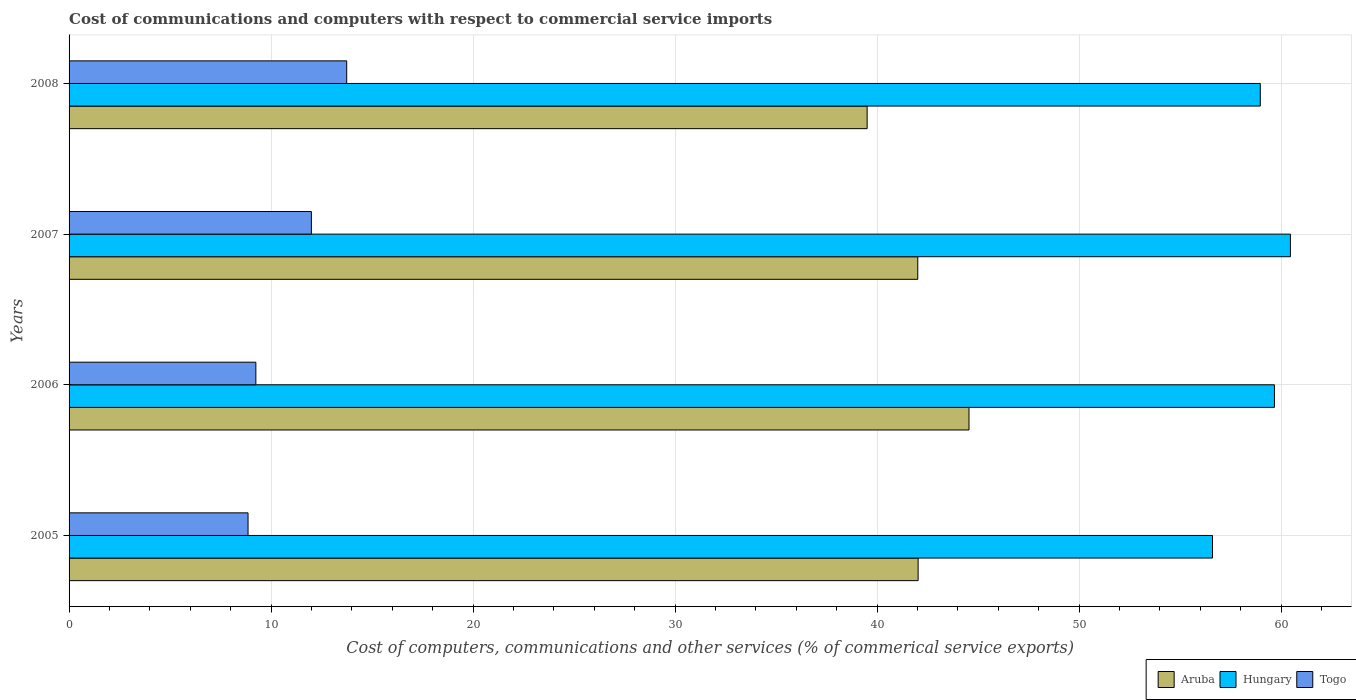Are the number of bars per tick equal to the number of legend labels?
Your response must be concise. Yes. How many bars are there on the 3rd tick from the top?
Your answer should be compact. 3. What is the label of the 3rd group of bars from the top?
Make the answer very short. 2006. In how many cases, is the number of bars for a given year not equal to the number of legend labels?
Ensure brevity in your answer.  0. What is the cost of communications and computers in Aruba in 2005?
Offer a terse response. 42.03. Across all years, what is the maximum cost of communications and computers in Hungary?
Provide a short and direct response. 60.46. Across all years, what is the minimum cost of communications and computers in Hungary?
Your answer should be compact. 56.61. What is the total cost of communications and computers in Togo in the graph?
Your response must be concise. 43.85. What is the difference between the cost of communications and computers in Aruba in 2007 and that in 2008?
Provide a succinct answer. 2.51. What is the difference between the cost of communications and computers in Togo in 2008 and the cost of communications and computers in Aruba in 2007?
Your answer should be compact. -28.27. What is the average cost of communications and computers in Hungary per year?
Offer a very short reply. 58.93. In the year 2005, what is the difference between the cost of communications and computers in Togo and cost of communications and computers in Hungary?
Give a very brief answer. -47.75. What is the ratio of the cost of communications and computers in Togo in 2007 to that in 2008?
Ensure brevity in your answer.  0.87. Is the difference between the cost of communications and computers in Togo in 2006 and 2007 greater than the difference between the cost of communications and computers in Hungary in 2006 and 2007?
Provide a short and direct response. No. What is the difference between the highest and the second highest cost of communications and computers in Togo?
Ensure brevity in your answer.  1.75. What is the difference between the highest and the lowest cost of communications and computers in Hungary?
Ensure brevity in your answer.  3.86. In how many years, is the cost of communications and computers in Aruba greater than the average cost of communications and computers in Aruba taken over all years?
Offer a very short reply. 2. Is the sum of the cost of communications and computers in Togo in 2005 and 2008 greater than the maximum cost of communications and computers in Aruba across all years?
Ensure brevity in your answer.  No. What does the 2nd bar from the top in 2008 represents?
Make the answer very short. Hungary. What does the 1st bar from the bottom in 2006 represents?
Offer a very short reply. Aruba. Are all the bars in the graph horizontal?
Offer a terse response. Yes. What is the difference between two consecutive major ticks on the X-axis?
Offer a very short reply. 10. Are the values on the major ticks of X-axis written in scientific E-notation?
Provide a short and direct response. No. How are the legend labels stacked?
Ensure brevity in your answer.  Horizontal. What is the title of the graph?
Keep it short and to the point. Cost of communications and computers with respect to commercial service imports. Does "Azerbaijan" appear as one of the legend labels in the graph?
Offer a terse response. No. What is the label or title of the X-axis?
Your answer should be compact. Cost of computers, communications and other services (% of commerical service exports). What is the Cost of computers, communications and other services (% of commerical service exports) in Aruba in 2005?
Your response must be concise. 42.03. What is the Cost of computers, communications and other services (% of commerical service exports) of Hungary in 2005?
Ensure brevity in your answer.  56.61. What is the Cost of computers, communications and other services (% of commerical service exports) of Togo in 2005?
Your response must be concise. 8.86. What is the Cost of computers, communications and other services (% of commerical service exports) of Aruba in 2006?
Offer a very short reply. 44.55. What is the Cost of computers, communications and other services (% of commerical service exports) in Hungary in 2006?
Make the answer very short. 59.67. What is the Cost of computers, communications and other services (% of commerical service exports) in Togo in 2006?
Your answer should be very brief. 9.25. What is the Cost of computers, communications and other services (% of commerical service exports) in Aruba in 2007?
Offer a very short reply. 42.01. What is the Cost of computers, communications and other services (% of commerical service exports) in Hungary in 2007?
Keep it short and to the point. 60.46. What is the Cost of computers, communications and other services (% of commerical service exports) in Togo in 2007?
Provide a short and direct response. 11.99. What is the Cost of computers, communications and other services (% of commerical service exports) in Aruba in 2008?
Your answer should be very brief. 39.51. What is the Cost of computers, communications and other services (% of commerical service exports) of Hungary in 2008?
Provide a succinct answer. 58.97. What is the Cost of computers, communications and other services (% of commerical service exports) of Togo in 2008?
Provide a short and direct response. 13.74. Across all years, what is the maximum Cost of computers, communications and other services (% of commerical service exports) of Aruba?
Make the answer very short. 44.55. Across all years, what is the maximum Cost of computers, communications and other services (% of commerical service exports) of Hungary?
Keep it short and to the point. 60.46. Across all years, what is the maximum Cost of computers, communications and other services (% of commerical service exports) of Togo?
Make the answer very short. 13.74. Across all years, what is the minimum Cost of computers, communications and other services (% of commerical service exports) of Aruba?
Offer a terse response. 39.51. Across all years, what is the minimum Cost of computers, communications and other services (% of commerical service exports) of Hungary?
Keep it short and to the point. 56.61. Across all years, what is the minimum Cost of computers, communications and other services (% of commerical service exports) of Togo?
Your response must be concise. 8.86. What is the total Cost of computers, communications and other services (% of commerical service exports) in Aruba in the graph?
Offer a terse response. 168.11. What is the total Cost of computers, communications and other services (% of commerical service exports) in Hungary in the graph?
Ensure brevity in your answer.  235.71. What is the total Cost of computers, communications and other services (% of commerical service exports) of Togo in the graph?
Make the answer very short. 43.85. What is the difference between the Cost of computers, communications and other services (% of commerical service exports) of Aruba in 2005 and that in 2006?
Offer a very short reply. -2.52. What is the difference between the Cost of computers, communications and other services (% of commerical service exports) of Hungary in 2005 and that in 2006?
Make the answer very short. -3.06. What is the difference between the Cost of computers, communications and other services (% of commerical service exports) in Togo in 2005 and that in 2006?
Offer a very short reply. -0.39. What is the difference between the Cost of computers, communications and other services (% of commerical service exports) of Aruba in 2005 and that in 2007?
Offer a terse response. 0.02. What is the difference between the Cost of computers, communications and other services (% of commerical service exports) of Hungary in 2005 and that in 2007?
Ensure brevity in your answer.  -3.86. What is the difference between the Cost of computers, communications and other services (% of commerical service exports) in Togo in 2005 and that in 2007?
Keep it short and to the point. -3.14. What is the difference between the Cost of computers, communications and other services (% of commerical service exports) of Aruba in 2005 and that in 2008?
Keep it short and to the point. 2.52. What is the difference between the Cost of computers, communications and other services (% of commerical service exports) in Hungary in 2005 and that in 2008?
Provide a short and direct response. -2.36. What is the difference between the Cost of computers, communications and other services (% of commerical service exports) of Togo in 2005 and that in 2008?
Offer a very short reply. -4.88. What is the difference between the Cost of computers, communications and other services (% of commerical service exports) of Aruba in 2006 and that in 2007?
Your answer should be compact. 2.54. What is the difference between the Cost of computers, communications and other services (% of commerical service exports) of Hungary in 2006 and that in 2007?
Your response must be concise. -0.79. What is the difference between the Cost of computers, communications and other services (% of commerical service exports) of Togo in 2006 and that in 2007?
Ensure brevity in your answer.  -2.75. What is the difference between the Cost of computers, communications and other services (% of commerical service exports) of Aruba in 2006 and that in 2008?
Offer a terse response. 5.04. What is the difference between the Cost of computers, communications and other services (% of commerical service exports) of Hungary in 2006 and that in 2008?
Make the answer very short. 0.7. What is the difference between the Cost of computers, communications and other services (% of commerical service exports) in Togo in 2006 and that in 2008?
Ensure brevity in your answer.  -4.5. What is the difference between the Cost of computers, communications and other services (% of commerical service exports) of Aruba in 2007 and that in 2008?
Offer a very short reply. 2.51. What is the difference between the Cost of computers, communications and other services (% of commerical service exports) in Hungary in 2007 and that in 2008?
Make the answer very short. 1.49. What is the difference between the Cost of computers, communications and other services (% of commerical service exports) of Togo in 2007 and that in 2008?
Your answer should be very brief. -1.75. What is the difference between the Cost of computers, communications and other services (% of commerical service exports) in Aruba in 2005 and the Cost of computers, communications and other services (% of commerical service exports) in Hungary in 2006?
Keep it short and to the point. -17.64. What is the difference between the Cost of computers, communications and other services (% of commerical service exports) of Aruba in 2005 and the Cost of computers, communications and other services (% of commerical service exports) of Togo in 2006?
Offer a terse response. 32.78. What is the difference between the Cost of computers, communications and other services (% of commerical service exports) in Hungary in 2005 and the Cost of computers, communications and other services (% of commerical service exports) in Togo in 2006?
Offer a terse response. 47.36. What is the difference between the Cost of computers, communications and other services (% of commerical service exports) of Aruba in 2005 and the Cost of computers, communications and other services (% of commerical service exports) of Hungary in 2007?
Keep it short and to the point. -18.43. What is the difference between the Cost of computers, communications and other services (% of commerical service exports) of Aruba in 2005 and the Cost of computers, communications and other services (% of commerical service exports) of Togo in 2007?
Your answer should be very brief. 30.04. What is the difference between the Cost of computers, communications and other services (% of commerical service exports) in Hungary in 2005 and the Cost of computers, communications and other services (% of commerical service exports) in Togo in 2007?
Your answer should be very brief. 44.61. What is the difference between the Cost of computers, communications and other services (% of commerical service exports) of Aruba in 2005 and the Cost of computers, communications and other services (% of commerical service exports) of Hungary in 2008?
Keep it short and to the point. -16.94. What is the difference between the Cost of computers, communications and other services (% of commerical service exports) of Aruba in 2005 and the Cost of computers, communications and other services (% of commerical service exports) of Togo in 2008?
Offer a very short reply. 28.29. What is the difference between the Cost of computers, communications and other services (% of commerical service exports) in Hungary in 2005 and the Cost of computers, communications and other services (% of commerical service exports) in Togo in 2008?
Provide a short and direct response. 42.86. What is the difference between the Cost of computers, communications and other services (% of commerical service exports) in Aruba in 2006 and the Cost of computers, communications and other services (% of commerical service exports) in Hungary in 2007?
Make the answer very short. -15.91. What is the difference between the Cost of computers, communications and other services (% of commerical service exports) in Aruba in 2006 and the Cost of computers, communications and other services (% of commerical service exports) in Togo in 2007?
Offer a very short reply. 32.56. What is the difference between the Cost of computers, communications and other services (% of commerical service exports) of Hungary in 2006 and the Cost of computers, communications and other services (% of commerical service exports) of Togo in 2007?
Make the answer very short. 47.68. What is the difference between the Cost of computers, communications and other services (% of commerical service exports) of Aruba in 2006 and the Cost of computers, communications and other services (% of commerical service exports) of Hungary in 2008?
Make the answer very short. -14.42. What is the difference between the Cost of computers, communications and other services (% of commerical service exports) of Aruba in 2006 and the Cost of computers, communications and other services (% of commerical service exports) of Togo in 2008?
Give a very brief answer. 30.81. What is the difference between the Cost of computers, communications and other services (% of commerical service exports) of Hungary in 2006 and the Cost of computers, communications and other services (% of commerical service exports) of Togo in 2008?
Offer a very short reply. 45.93. What is the difference between the Cost of computers, communications and other services (% of commerical service exports) in Aruba in 2007 and the Cost of computers, communications and other services (% of commerical service exports) in Hungary in 2008?
Provide a succinct answer. -16.96. What is the difference between the Cost of computers, communications and other services (% of commerical service exports) of Aruba in 2007 and the Cost of computers, communications and other services (% of commerical service exports) of Togo in 2008?
Keep it short and to the point. 28.27. What is the difference between the Cost of computers, communications and other services (% of commerical service exports) of Hungary in 2007 and the Cost of computers, communications and other services (% of commerical service exports) of Togo in 2008?
Your answer should be compact. 46.72. What is the average Cost of computers, communications and other services (% of commerical service exports) of Aruba per year?
Your response must be concise. 42.03. What is the average Cost of computers, communications and other services (% of commerical service exports) in Hungary per year?
Offer a terse response. 58.93. What is the average Cost of computers, communications and other services (% of commerical service exports) in Togo per year?
Your answer should be very brief. 10.96. In the year 2005, what is the difference between the Cost of computers, communications and other services (% of commerical service exports) of Aruba and Cost of computers, communications and other services (% of commerical service exports) of Hungary?
Make the answer very short. -14.57. In the year 2005, what is the difference between the Cost of computers, communications and other services (% of commerical service exports) of Aruba and Cost of computers, communications and other services (% of commerical service exports) of Togo?
Provide a succinct answer. 33.17. In the year 2005, what is the difference between the Cost of computers, communications and other services (% of commerical service exports) of Hungary and Cost of computers, communications and other services (% of commerical service exports) of Togo?
Keep it short and to the point. 47.75. In the year 2006, what is the difference between the Cost of computers, communications and other services (% of commerical service exports) of Aruba and Cost of computers, communications and other services (% of commerical service exports) of Hungary?
Offer a terse response. -15.12. In the year 2006, what is the difference between the Cost of computers, communications and other services (% of commerical service exports) in Aruba and Cost of computers, communications and other services (% of commerical service exports) in Togo?
Offer a very short reply. 35.3. In the year 2006, what is the difference between the Cost of computers, communications and other services (% of commerical service exports) in Hungary and Cost of computers, communications and other services (% of commerical service exports) in Togo?
Offer a terse response. 50.42. In the year 2007, what is the difference between the Cost of computers, communications and other services (% of commerical service exports) of Aruba and Cost of computers, communications and other services (% of commerical service exports) of Hungary?
Make the answer very short. -18.45. In the year 2007, what is the difference between the Cost of computers, communications and other services (% of commerical service exports) of Aruba and Cost of computers, communications and other services (% of commerical service exports) of Togo?
Provide a short and direct response. 30.02. In the year 2007, what is the difference between the Cost of computers, communications and other services (% of commerical service exports) in Hungary and Cost of computers, communications and other services (% of commerical service exports) in Togo?
Provide a short and direct response. 48.47. In the year 2008, what is the difference between the Cost of computers, communications and other services (% of commerical service exports) of Aruba and Cost of computers, communications and other services (% of commerical service exports) of Hungary?
Provide a short and direct response. -19.46. In the year 2008, what is the difference between the Cost of computers, communications and other services (% of commerical service exports) in Aruba and Cost of computers, communications and other services (% of commerical service exports) in Togo?
Offer a very short reply. 25.76. In the year 2008, what is the difference between the Cost of computers, communications and other services (% of commerical service exports) in Hungary and Cost of computers, communications and other services (% of commerical service exports) in Togo?
Keep it short and to the point. 45.23. What is the ratio of the Cost of computers, communications and other services (% of commerical service exports) of Aruba in 2005 to that in 2006?
Offer a very short reply. 0.94. What is the ratio of the Cost of computers, communications and other services (% of commerical service exports) of Hungary in 2005 to that in 2006?
Provide a succinct answer. 0.95. What is the ratio of the Cost of computers, communications and other services (% of commerical service exports) in Togo in 2005 to that in 2006?
Make the answer very short. 0.96. What is the ratio of the Cost of computers, communications and other services (% of commerical service exports) of Aruba in 2005 to that in 2007?
Your response must be concise. 1. What is the ratio of the Cost of computers, communications and other services (% of commerical service exports) in Hungary in 2005 to that in 2007?
Your answer should be compact. 0.94. What is the ratio of the Cost of computers, communications and other services (% of commerical service exports) in Togo in 2005 to that in 2007?
Your answer should be very brief. 0.74. What is the ratio of the Cost of computers, communications and other services (% of commerical service exports) in Aruba in 2005 to that in 2008?
Offer a terse response. 1.06. What is the ratio of the Cost of computers, communications and other services (% of commerical service exports) in Hungary in 2005 to that in 2008?
Offer a very short reply. 0.96. What is the ratio of the Cost of computers, communications and other services (% of commerical service exports) in Togo in 2005 to that in 2008?
Offer a terse response. 0.64. What is the ratio of the Cost of computers, communications and other services (% of commerical service exports) in Aruba in 2006 to that in 2007?
Offer a terse response. 1.06. What is the ratio of the Cost of computers, communications and other services (% of commerical service exports) of Hungary in 2006 to that in 2007?
Provide a succinct answer. 0.99. What is the ratio of the Cost of computers, communications and other services (% of commerical service exports) in Togo in 2006 to that in 2007?
Your answer should be compact. 0.77. What is the ratio of the Cost of computers, communications and other services (% of commerical service exports) in Aruba in 2006 to that in 2008?
Make the answer very short. 1.13. What is the ratio of the Cost of computers, communications and other services (% of commerical service exports) of Hungary in 2006 to that in 2008?
Offer a terse response. 1.01. What is the ratio of the Cost of computers, communications and other services (% of commerical service exports) in Togo in 2006 to that in 2008?
Keep it short and to the point. 0.67. What is the ratio of the Cost of computers, communications and other services (% of commerical service exports) of Aruba in 2007 to that in 2008?
Provide a short and direct response. 1.06. What is the ratio of the Cost of computers, communications and other services (% of commerical service exports) in Hungary in 2007 to that in 2008?
Make the answer very short. 1.03. What is the ratio of the Cost of computers, communications and other services (% of commerical service exports) in Togo in 2007 to that in 2008?
Give a very brief answer. 0.87. What is the difference between the highest and the second highest Cost of computers, communications and other services (% of commerical service exports) of Aruba?
Ensure brevity in your answer.  2.52. What is the difference between the highest and the second highest Cost of computers, communications and other services (% of commerical service exports) in Hungary?
Keep it short and to the point. 0.79. What is the difference between the highest and the second highest Cost of computers, communications and other services (% of commerical service exports) in Togo?
Provide a succinct answer. 1.75. What is the difference between the highest and the lowest Cost of computers, communications and other services (% of commerical service exports) of Aruba?
Provide a succinct answer. 5.04. What is the difference between the highest and the lowest Cost of computers, communications and other services (% of commerical service exports) of Hungary?
Your answer should be very brief. 3.86. What is the difference between the highest and the lowest Cost of computers, communications and other services (% of commerical service exports) of Togo?
Offer a terse response. 4.88. 